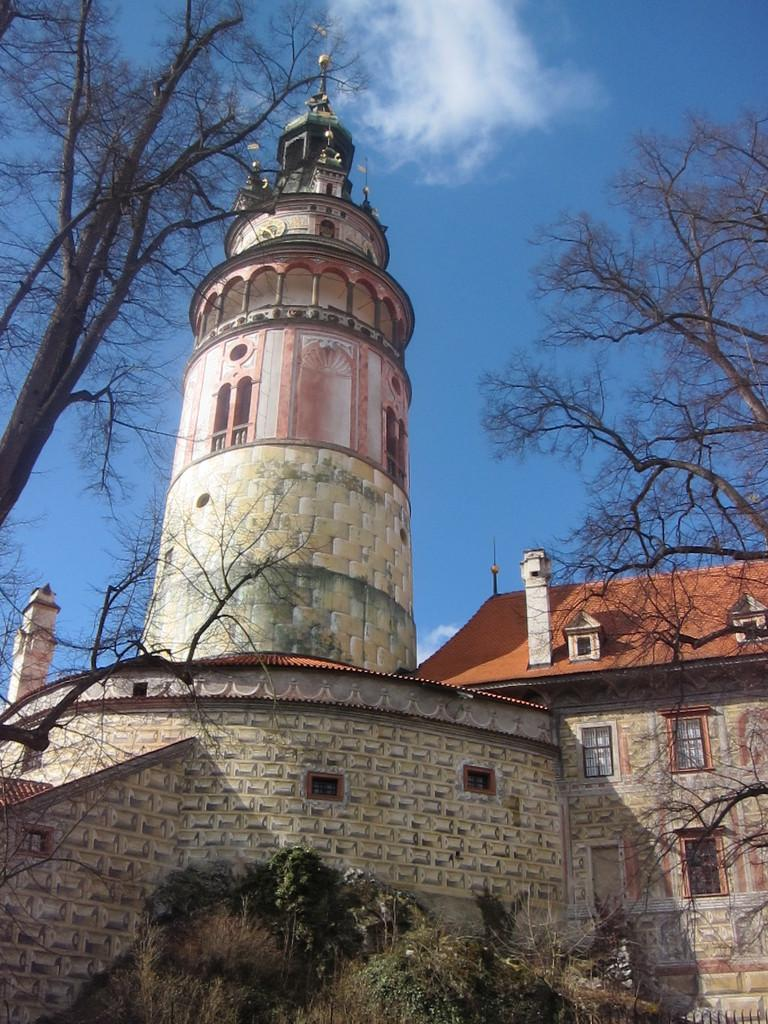What type of structures are present in the image? There are buildings in the image. What colors are the buildings? The buildings are in cream and white color. What can be seen in the background of the image? There are dried trees in the background of the image. What is the color of the sky in the image? The sky is blue and white in color. Can you see any wounds on the buildings in the image? There are no wounds visible on the buildings in the image. Is there a mother figure present in the image? There is no mother figure mentioned or visible in the image. 